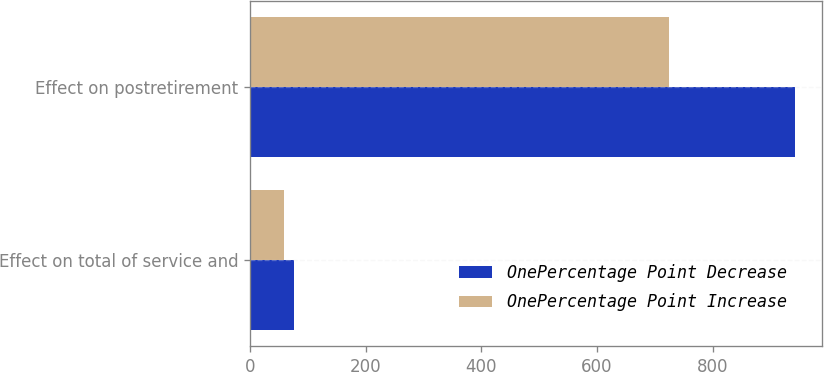<chart> <loc_0><loc_0><loc_500><loc_500><stacked_bar_chart><ecel><fcel>Effect on total of service and<fcel>Effect on postretirement<nl><fcel>OnePercentage Point Decrease<fcel>76<fcel>942<nl><fcel>OnePercentage Point Increase<fcel>59<fcel>724<nl></chart> 